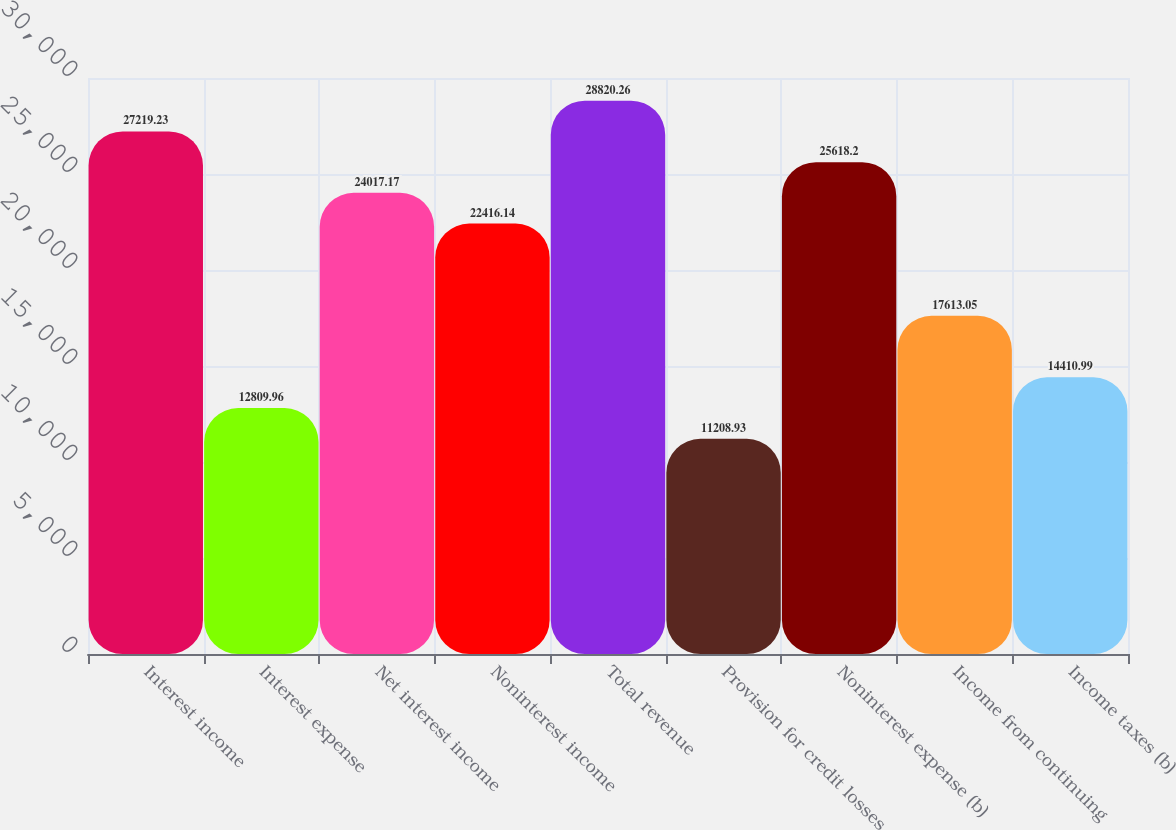Convert chart. <chart><loc_0><loc_0><loc_500><loc_500><bar_chart><fcel>Interest income<fcel>Interest expense<fcel>Net interest income<fcel>Noninterest income<fcel>Total revenue<fcel>Provision for credit losses<fcel>Noninterest expense (b)<fcel>Income from continuing<fcel>Income taxes (b)<nl><fcel>27219.2<fcel>12810<fcel>24017.2<fcel>22416.1<fcel>28820.3<fcel>11208.9<fcel>25618.2<fcel>17613<fcel>14411<nl></chart> 